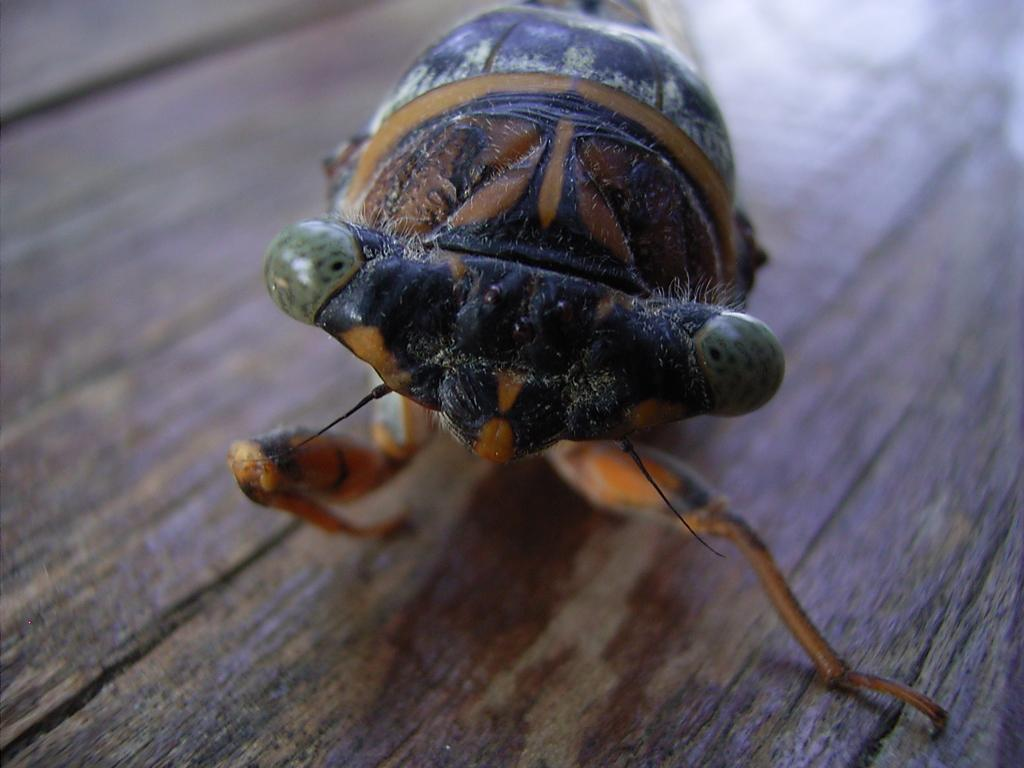What type of creature can be seen in the image? There is an insect in the image. Where is the insect located? The insect is on a wooden surface. What type of quilt is being used to cover the insect in the image? There is no quilt present in the image; the insect is on a wooden surface. Is the insect bleeding in the image? There is no indication of blood or injury to the insect in the image. 